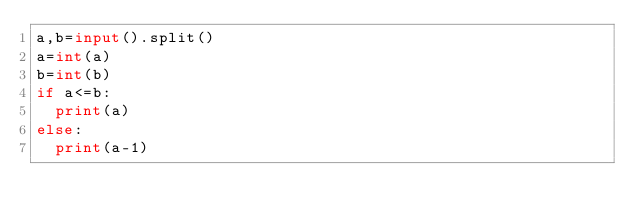<code> <loc_0><loc_0><loc_500><loc_500><_Python_>a,b=input().split()
a=int(a)
b=int(b)
if a<=b:
  print(a)
else:
  print(a-1)</code> 